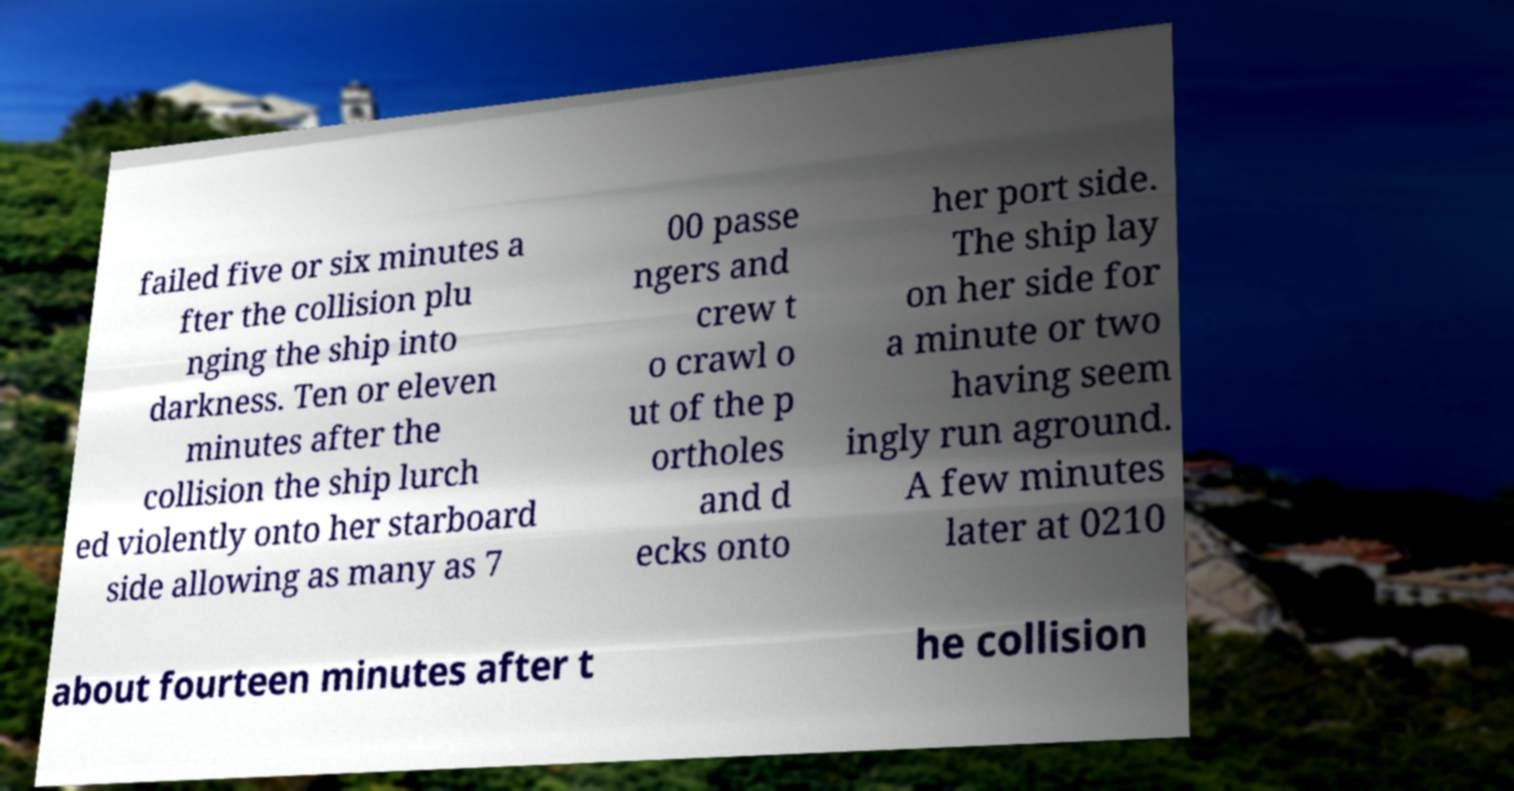Could you extract and type out the text from this image? failed five or six minutes a fter the collision plu nging the ship into darkness. Ten or eleven minutes after the collision the ship lurch ed violently onto her starboard side allowing as many as 7 00 passe ngers and crew t o crawl o ut of the p ortholes and d ecks onto her port side. The ship lay on her side for a minute or two having seem ingly run aground. A few minutes later at 0210 about fourteen minutes after t he collision 